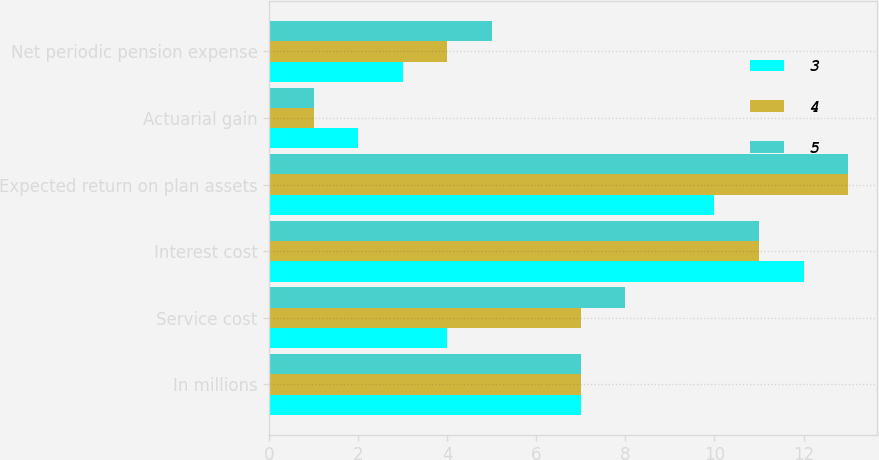<chart> <loc_0><loc_0><loc_500><loc_500><stacked_bar_chart><ecel><fcel>In millions<fcel>Service cost<fcel>Interest cost<fcel>Expected return on plan assets<fcel>Actuarial gain<fcel>Net periodic pension expense<nl><fcel>3<fcel>7<fcel>4<fcel>12<fcel>10<fcel>2<fcel>3<nl><fcel>4<fcel>7<fcel>7<fcel>11<fcel>13<fcel>1<fcel>4<nl><fcel>5<fcel>7<fcel>8<fcel>11<fcel>13<fcel>1<fcel>5<nl></chart> 